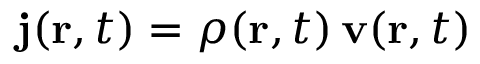Convert formula to latex. <formula><loc_0><loc_0><loc_500><loc_500>j ( r , t ) = \rho ( r , t ) \, v ( r , t )</formula> 